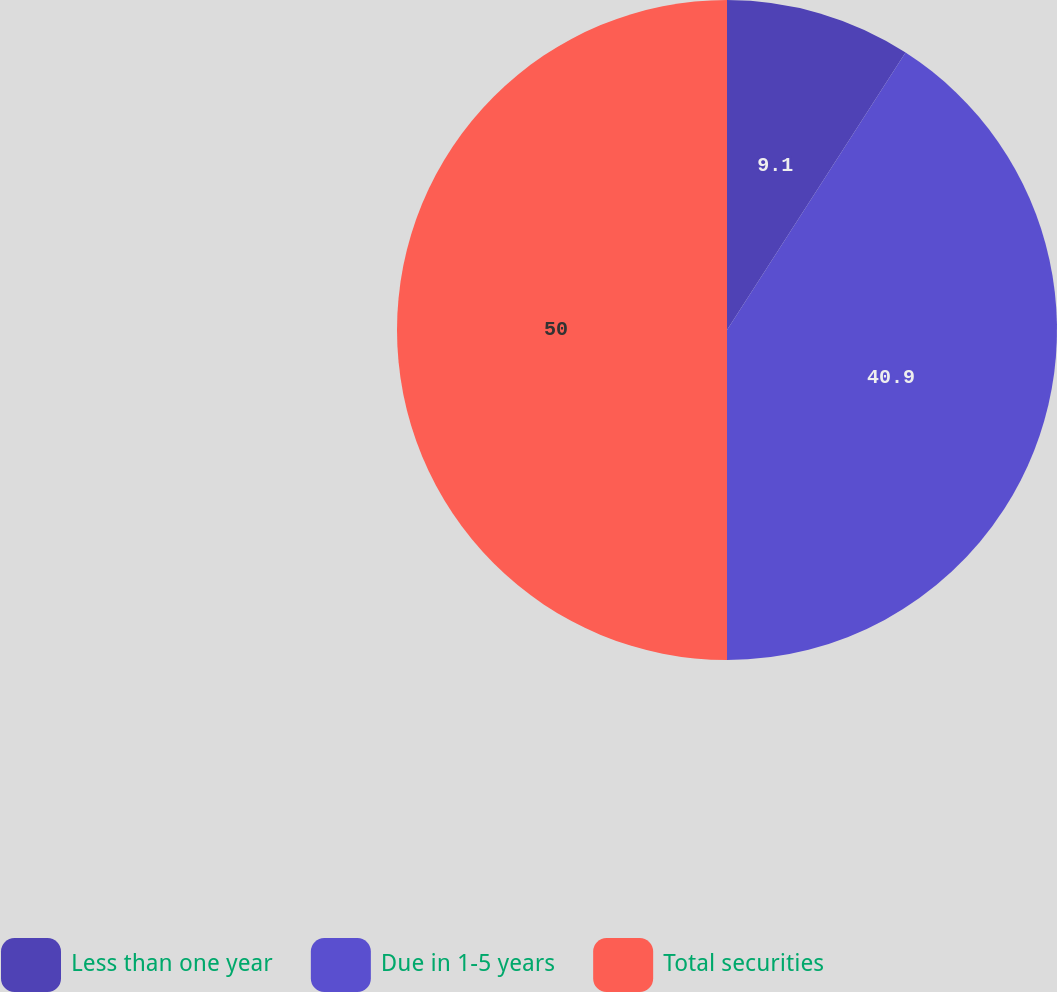<chart> <loc_0><loc_0><loc_500><loc_500><pie_chart><fcel>Less than one year<fcel>Due in 1-5 years<fcel>Total securities<nl><fcel>9.1%<fcel>40.9%<fcel>50.0%<nl></chart> 